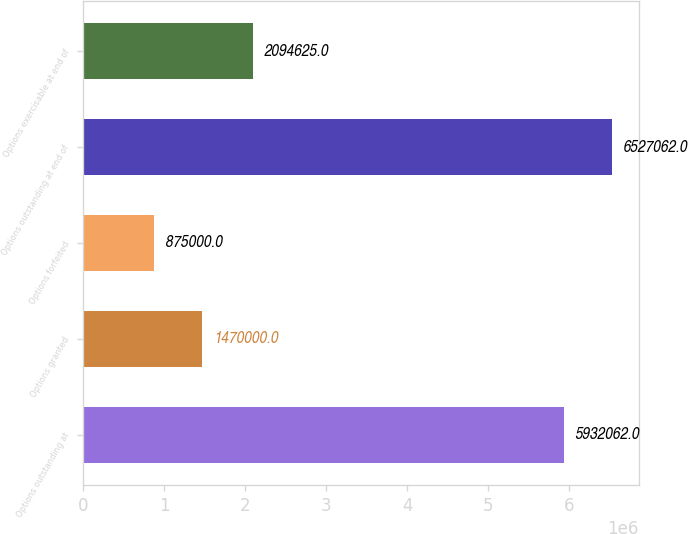Convert chart to OTSL. <chart><loc_0><loc_0><loc_500><loc_500><bar_chart><fcel>Options outstanding at<fcel>Options granted<fcel>Options forfeited<fcel>Options outstanding at end of<fcel>Options exercisable at end of<nl><fcel>5.93206e+06<fcel>1.47e+06<fcel>875000<fcel>6.52706e+06<fcel>2.09462e+06<nl></chart> 